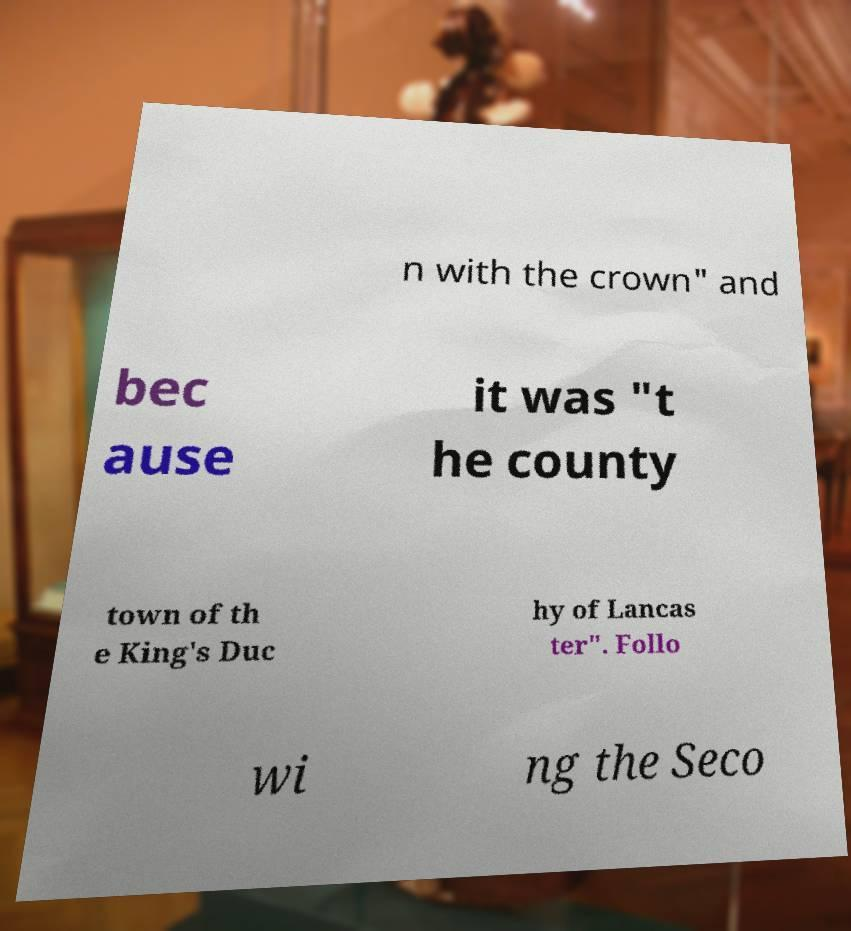Could you extract and type out the text from this image? n with the crown" and bec ause it was "t he county town of th e King's Duc hy of Lancas ter". Follo wi ng the Seco 